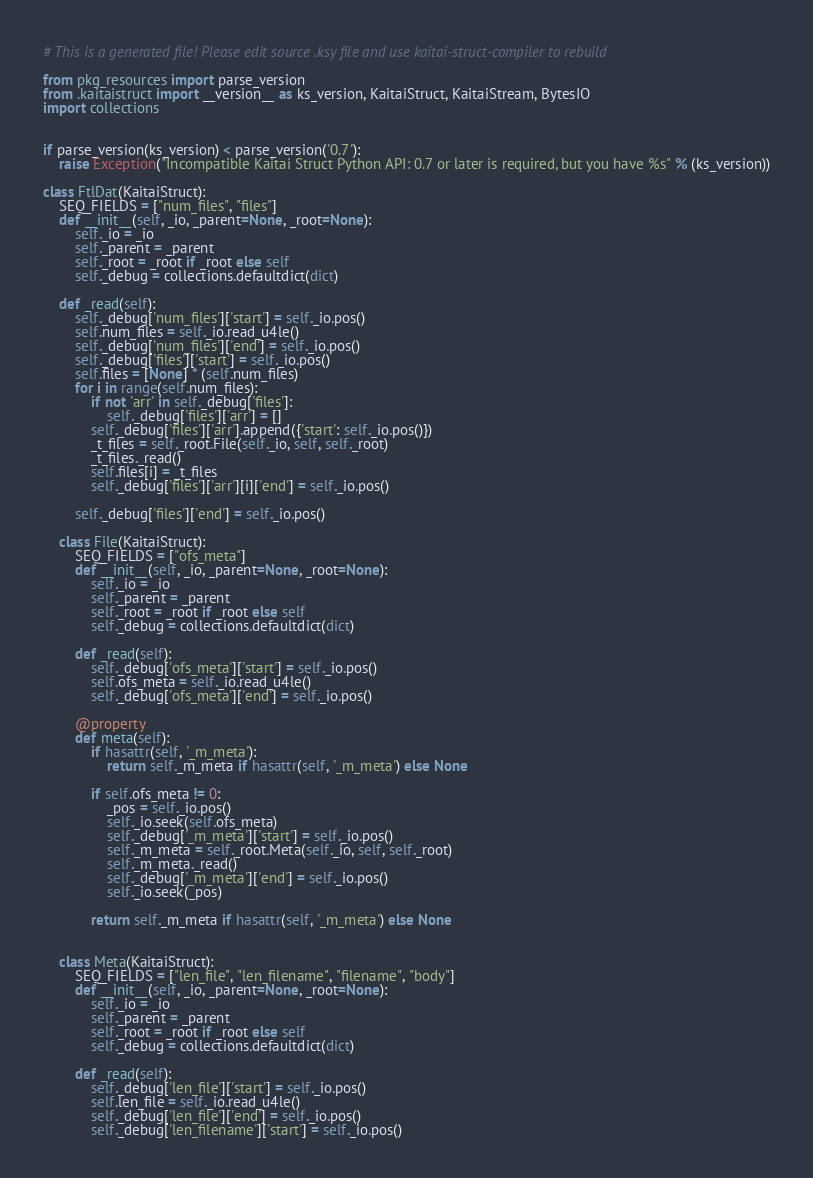<code> <loc_0><loc_0><loc_500><loc_500><_Python_># This is a generated file! Please edit source .ksy file and use kaitai-struct-compiler to rebuild

from pkg_resources import parse_version
from .kaitaistruct import __version__ as ks_version, KaitaiStruct, KaitaiStream, BytesIO
import collections


if parse_version(ks_version) < parse_version('0.7'):
    raise Exception("Incompatible Kaitai Struct Python API: 0.7 or later is required, but you have %s" % (ks_version))

class FtlDat(KaitaiStruct):
    SEQ_FIELDS = ["num_files", "files"]
    def __init__(self, _io, _parent=None, _root=None):
        self._io = _io
        self._parent = _parent
        self._root = _root if _root else self
        self._debug = collections.defaultdict(dict)

    def _read(self):
        self._debug['num_files']['start'] = self._io.pos()
        self.num_files = self._io.read_u4le()
        self._debug['num_files']['end'] = self._io.pos()
        self._debug['files']['start'] = self._io.pos()
        self.files = [None] * (self.num_files)
        for i in range(self.num_files):
            if not 'arr' in self._debug['files']:
                self._debug['files']['arr'] = []
            self._debug['files']['arr'].append({'start': self._io.pos()})
            _t_files = self._root.File(self._io, self, self._root)
            _t_files._read()
            self.files[i] = _t_files
            self._debug['files']['arr'][i]['end'] = self._io.pos()

        self._debug['files']['end'] = self._io.pos()

    class File(KaitaiStruct):
        SEQ_FIELDS = ["ofs_meta"]
        def __init__(self, _io, _parent=None, _root=None):
            self._io = _io
            self._parent = _parent
            self._root = _root if _root else self
            self._debug = collections.defaultdict(dict)

        def _read(self):
            self._debug['ofs_meta']['start'] = self._io.pos()
            self.ofs_meta = self._io.read_u4le()
            self._debug['ofs_meta']['end'] = self._io.pos()

        @property
        def meta(self):
            if hasattr(self, '_m_meta'):
                return self._m_meta if hasattr(self, '_m_meta') else None

            if self.ofs_meta != 0:
                _pos = self._io.pos()
                self._io.seek(self.ofs_meta)
                self._debug['_m_meta']['start'] = self._io.pos()
                self._m_meta = self._root.Meta(self._io, self, self._root)
                self._m_meta._read()
                self._debug['_m_meta']['end'] = self._io.pos()
                self._io.seek(_pos)

            return self._m_meta if hasattr(self, '_m_meta') else None


    class Meta(KaitaiStruct):
        SEQ_FIELDS = ["len_file", "len_filename", "filename", "body"]
        def __init__(self, _io, _parent=None, _root=None):
            self._io = _io
            self._parent = _parent
            self._root = _root if _root else self
            self._debug = collections.defaultdict(dict)

        def _read(self):
            self._debug['len_file']['start'] = self._io.pos()
            self.len_file = self._io.read_u4le()
            self._debug['len_file']['end'] = self._io.pos()
            self._debug['len_filename']['start'] = self._io.pos()</code> 